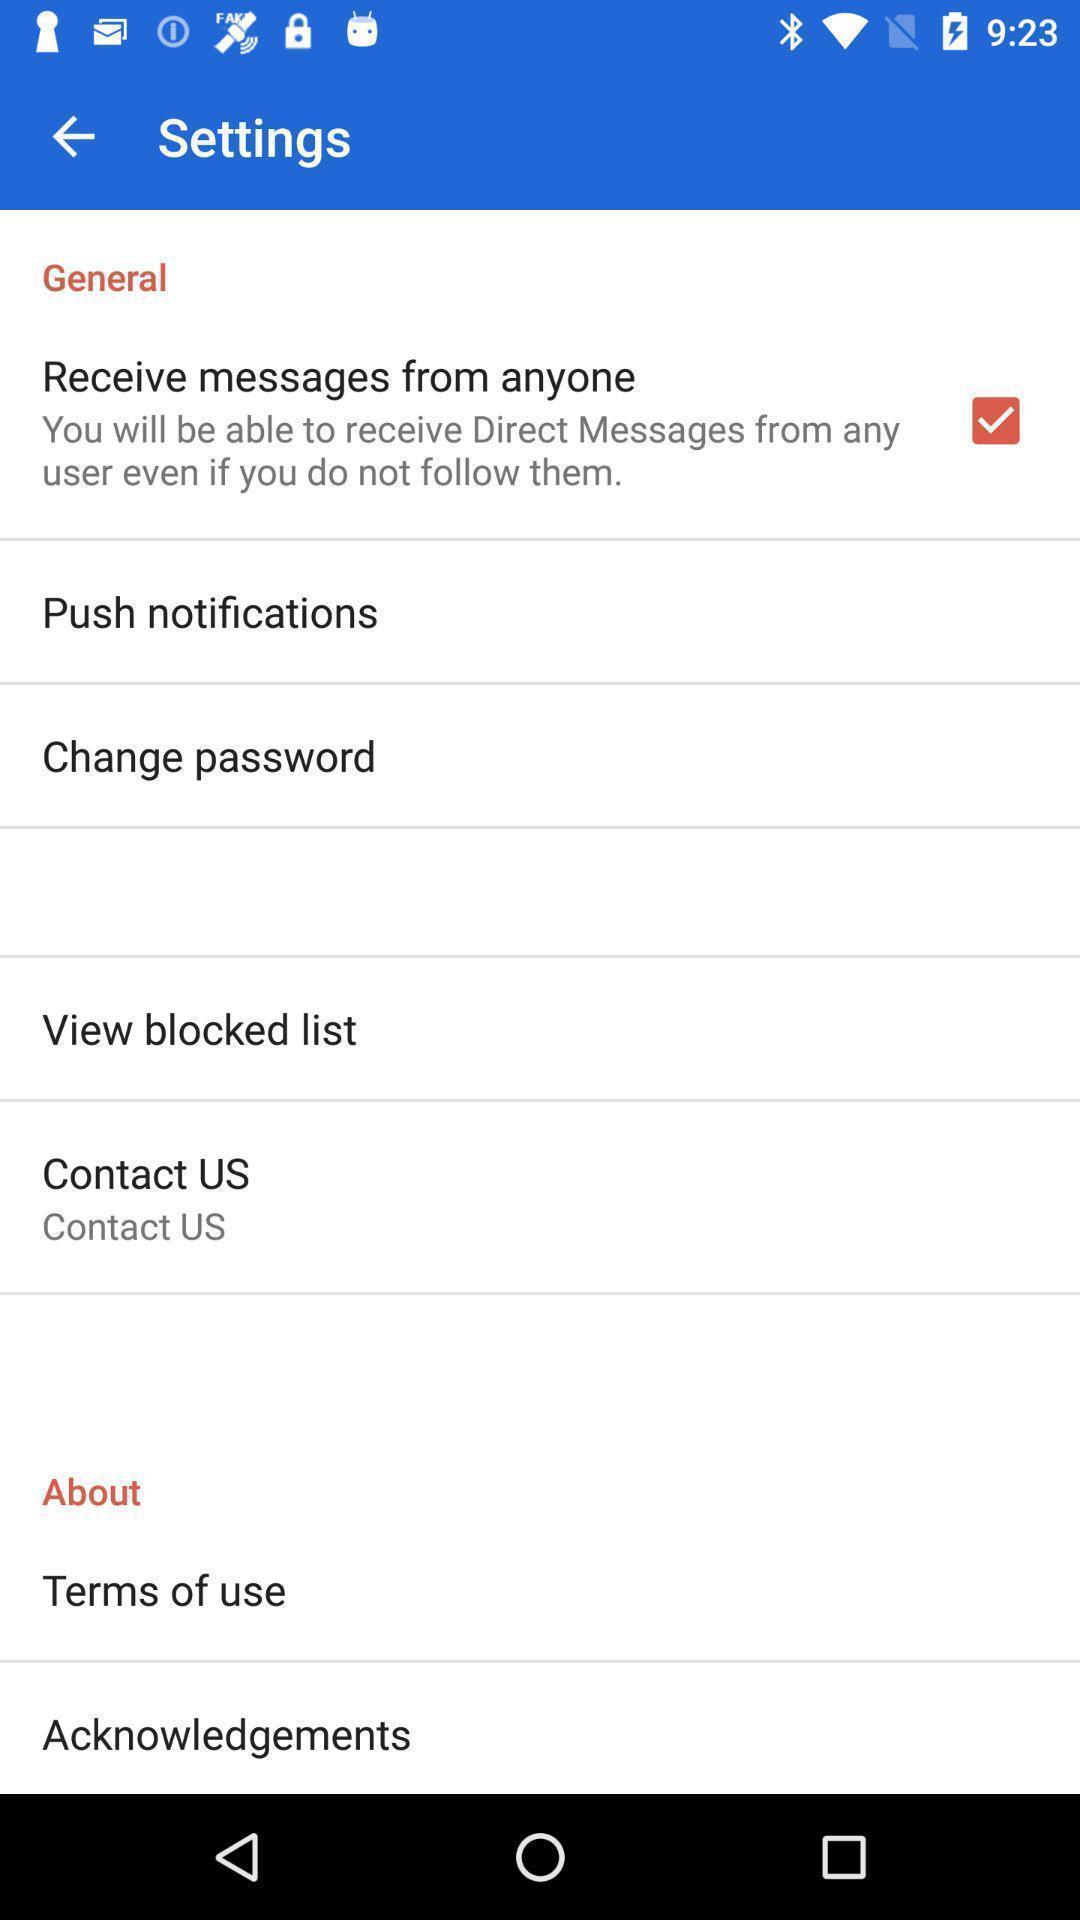Give me a summary of this screen capture. Settings page. 